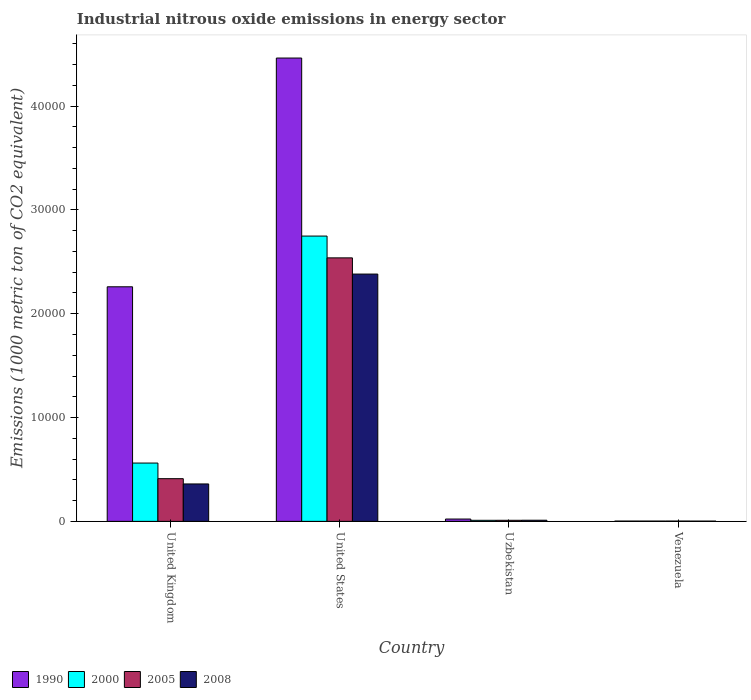How many groups of bars are there?
Make the answer very short. 4. Are the number of bars on each tick of the X-axis equal?
Provide a short and direct response. Yes. How many bars are there on the 1st tick from the right?
Provide a short and direct response. 4. What is the label of the 1st group of bars from the left?
Make the answer very short. United Kingdom. In how many cases, is the number of bars for a given country not equal to the number of legend labels?
Your answer should be compact. 0. What is the amount of industrial nitrous oxide emitted in 2005 in Uzbekistan?
Make the answer very short. 103.2. Across all countries, what is the maximum amount of industrial nitrous oxide emitted in 2000?
Give a very brief answer. 2.75e+04. Across all countries, what is the minimum amount of industrial nitrous oxide emitted in 1990?
Ensure brevity in your answer.  27.9. In which country was the amount of industrial nitrous oxide emitted in 1990 maximum?
Provide a succinct answer. United States. In which country was the amount of industrial nitrous oxide emitted in 2008 minimum?
Offer a terse response. Venezuela. What is the total amount of industrial nitrous oxide emitted in 1990 in the graph?
Ensure brevity in your answer.  6.75e+04. What is the difference between the amount of industrial nitrous oxide emitted in 1990 in United Kingdom and that in United States?
Offer a very short reply. -2.20e+04. What is the difference between the amount of industrial nitrous oxide emitted in 2008 in Venezuela and the amount of industrial nitrous oxide emitted in 2000 in Uzbekistan?
Your response must be concise. -76.2. What is the average amount of industrial nitrous oxide emitted in 1990 per country?
Your answer should be compact. 1.69e+04. What is the difference between the amount of industrial nitrous oxide emitted of/in 2005 and amount of industrial nitrous oxide emitted of/in 2008 in United Kingdom?
Keep it short and to the point. 506.6. What is the ratio of the amount of industrial nitrous oxide emitted in 2005 in United Kingdom to that in Uzbekistan?
Your answer should be very brief. 39.84. Is the amount of industrial nitrous oxide emitted in 1990 in United States less than that in Venezuela?
Your answer should be compact. No. What is the difference between the highest and the second highest amount of industrial nitrous oxide emitted in 2005?
Ensure brevity in your answer.  2.53e+04. What is the difference between the highest and the lowest amount of industrial nitrous oxide emitted in 2008?
Offer a terse response. 2.38e+04. Is the sum of the amount of industrial nitrous oxide emitted in 2008 in United Kingdom and United States greater than the maximum amount of industrial nitrous oxide emitted in 2005 across all countries?
Ensure brevity in your answer.  Yes. What does the 1st bar from the left in United Kingdom represents?
Provide a short and direct response. 1990. Is it the case that in every country, the sum of the amount of industrial nitrous oxide emitted in 2000 and amount of industrial nitrous oxide emitted in 1990 is greater than the amount of industrial nitrous oxide emitted in 2008?
Provide a short and direct response. Yes. What is the difference between two consecutive major ticks on the Y-axis?
Offer a very short reply. 10000. Are the values on the major ticks of Y-axis written in scientific E-notation?
Make the answer very short. No. Does the graph contain grids?
Ensure brevity in your answer.  No. How are the legend labels stacked?
Offer a terse response. Horizontal. What is the title of the graph?
Your answer should be compact. Industrial nitrous oxide emissions in energy sector. What is the label or title of the Y-axis?
Ensure brevity in your answer.  Emissions (1000 metric ton of CO2 equivalent). What is the Emissions (1000 metric ton of CO2 equivalent) of 1990 in United Kingdom?
Keep it short and to the point. 2.26e+04. What is the Emissions (1000 metric ton of CO2 equivalent) in 2000 in United Kingdom?
Offer a very short reply. 5616. What is the Emissions (1000 metric ton of CO2 equivalent) of 2005 in United Kingdom?
Keep it short and to the point. 4111.2. What is the Emissions (1000 metric ton of CO2 equivalent) in 2008 in United Kingdom?
Keep it short and to the point. 3604.6. What is the Emissions (1000 metric ton of CO2 equivalent) of 1990 in United States?
Offer a very short reply. 4.46e+04. What is the Emissions (1000 metric ton of CO2 equivalent) in 2000 in United States?
Offer a very short reply. 2.75e+04. What is the Emissions (1000 metric ton of CO2 equivalent) in 2005 in United States?
Your answer should be very brief. 2.54e+04. What is the Emissions (1000 metric ton of CO2 equivalent) of 2008 in United States?
Your answer should be very brief. 2.38e+04. What is the Emissions (1000 metric ton of CO2 equivalent) of 1990 in Uzbekistan?
Offer a very short reply. 223.2. What is the Emissions (1000 metric ton of CO2 equivalent) of 2000 in Uzbekistan?
Offer a very short reply. 101.6. What is the Emissions (1000 metric ton of CO2 equivalent) in 2005 in Uzbekistan?
Keep it short and to the point. 103.2. What is the Emissions (1000 metric ton of CO2 equivalent) in 2008 in Uzbekistan?
Provide a succinct answer. 109.4. What is the Emissions (1000 metric ton of CO2 equivalent) in 1990 in Venezuela?
Offer a terse response. 27.9. What is the Emissions (1000 metric ton of CO2 equivalent) of 2000 in Venezuela?
Keep it short and to the point. 27.9. What is the Emissions (1000 metric ton of CO2 equivalent) of 2005 in Venezuela?
Your answer should be compact. 30.1. What is the Emissions (1000 metric ton of CO2 equivalent) of 2008 in Venezuela?
Offer a very short reply. 25.4. Across all countries, what is the maximum Emissions (1000 metric ton of CO2 equivalent) of 1990?
Give a very brief answer. 4.46e+04. Across all countries, what is the maximum Emissions (1000 metric ton of CO2 equivalent) in 2000?
Ensure brevity in your answer.  2.75e+04. Across all countries, what is the maximum Emissions (1000 metric ton of CO2 equivalent) of 2005?
Offer a very short reply. 2.54e+04. Across all countries, what is the maximum Emissions (1000 metric ton of CO2 equivalent) of 2008?
Make the answer very short. 2.38e+04. Across all countries, what is the minimum Emissions (1000 metric ton of CO2 equivalent) in 1990?
Give a very brief answer. 27.9. Across all countries, what is the minimum Emissions (1000 metric ton of CO2 equivalent) in 2000?
Provide a succinct answer. 27.9. Across all countries, what is the minimum Emissions (1000 metric ton of CO2 equivalent) in 2005?
Keep it short and to the point. 30.1. Across all countries, what is the minimum Emissions (1000 metric ton of CO2 equivalent) in 2008?
Keep it short and to the point. 25.4. What is the total Emissions (1000 metric ton of CO2 equivalent) in 1990 in the graph?
Your answer should be compact. 6.75e+04. What is the total Emissions (1000 metric ton of CO2 equivalent) of 2000 in the graph?
Keep it short and to the point. 3.32e+04. What is the total Emissions (1000 metric ton of CO2 equivalent) of 2005 in the graph?
Provide a short and direct response. 2.96e+04. What is the total Emissions (1000 metric ton of CO2 equivalent) of 2008 in the graph?
Your answer should be very brief. 2.76e+04. What is the difference between the Emissions (1000 metric ton of CO2 equivalent) of 1990 in United Kingdom and that in United States?
Your answer should be very brief. -2.20e+04. What is the difference between the Emissions (1000 metric ton of CO2 equivalent) of 2000 in United Kingdom and that in United States?
Give a very brief answer. -2.19e+04. What is the difference between the Emissions (1000 metric ton of CO2 equivalent) of 2005 in United Kingdom and that in United States?
Your answer should be very brief. -2.13e+04. What is the difference between the Emissions (1000 metric ton of CO2 equivalent) in 2008 in United Kingdom and that in United States?
Your answer should be compact. -2.02e+04. What is the difference between the Emissions (1000 metric ton of CO2 equivalent) of 1990 in United Kingdom and that in Uzbekistan?
Offer a terse response. 2.24e+04. What is the difference between the Emissions (1000 metric ton of CO2 equivalent) in 2000 in United Kingdom and that in Uzbekistan?
Offer a very short reply. 5514.4. What is the difference between the Emissions (1000 metric ton of CO2 equivalent) of 2005 in United Kingdom and that in Uzbekistan?
Give a very brief answer. 4008. What is the difference between the Emissions (1000 metric ton of CO2 equivalent) in 2008 in United Kingdom and that in Uzbekistan?
Offer a very short reply. 3495.2. What is the difference between the Emissions (1000 metric ton of CO2 equivalent) of 1990 in United Kingdom and that in Venezuela?
Make the answer very short. 2.26e+04. What is the difference between the Emissions (1000 metric ton of CO2 equivalent) of 2000 in United Kingdom and that in Venezuela?
Offer a terse response. 5588.1. What is the difference between the Emissions (1000 metric ton of CO2 equivalent) of 2005 in United Kingdom and that in Venezuela?
Provide a short and direct response. 4081.1. What is the difference between the Emissions (1000 metric ton of CO2 equivalent) in 2008 in United Kingdom and that in Venezuela?
Your response must be concise. 3579.2. What is the difference between the Emissions (1000 metric ton of CO2 equivalent) of 1990 in United States and that in Uzbekistan?
Your response must be concise. 4.44e+04. What is the difference between the Emissions (1000 metric ton of CO2 equivalent) in 2000 in United States and that in Uzbekistan?
Make the answer very short. 2.74e+04. What is the difference between the Emissions (1000 metric ton of CO2 equivalent) of 2005 in United States and that in Uzbekistan?
Give a very brief answer. 2.53e+04. What is the difference between the Emissions (1000 metric ton of CO2 equivalent) in 2008 in United States and that in Uzbekistan?
Provide a short and direct response. 2.37e+04. What is the difference between the Emissions (1000 metric ton of CO2 equivalent) in 1990 in United States and that in Venezuela?
Your answer should be very brief. 4.46e+04. What is the difference between the Emissions (1000 metric ton of CO2 equivalent) in 2000 in United States and that in Venezuela?
Provide a succinct answer. 2.74e+04. What is the difference between the Emissions (1000 metric ton of CO2 equivalent) in 2005 in United States and that in Venezuela?
Offer a terse response. 2.53e+04. What is the difference between the Emissions (1000 metric ton of CO2 equivalent) of 2008 in United States and that in Venezuela?
Provide a short and direct response. 2.38e+04. What is the difference between the Emissions (1000 metric ton of CO2 equivalent) in 1990 in Uzbekistan and that in Venezuela?
Give a very brief answer. 195.3. What is the difference between the Emissions (1000 metric ton of CO2 equivalent) in 2000 in Uzbekistan and that in Venezuela?
Your answer should be very brief. 73.7. What is the difference between the Emissions (1000 metric ton of CO2 equivalent) in 2005 in Uzbekistan and that in Venezuela?
Your answer should be compact. 73.1. What is the difference between the Emissions (1000 metric ton of CO2 equivalent) in 1990 in United Kingdom and the Emissions (1000 metric ton of CO2 equivalent) in 2000 in United States?
Offer a very short reply. -4884.9. What is the difference between the Emissions (1000 metric ton of CO2 equivalent) of 1990 in United Kingdom and the Emissions (1000 metric ton of CO2 equivalent) of 2005 in United States?
Keep it short and to the point. -2785.7. What is the difference between the Emissions (1000 metric ton of CO2 equivalent) of 1990 in United Kingdom and the Emissions (1000 metric ton of CO2 equivalent) of 2008 in United States?
Make the answer very short. -1224.8. What is the difference between the Emissions (1000 metric ton of CO2 equivalent) in 2000 in United Kingdom and the Emissions (1000 metric ton of CO2 equivalent) in 2005 in United States?
Your answer should be very brief. -1.98e+04. What is the difference between the Emissions (1000 metric ton of CO2 equivalent) of 2000 in United Kingdom and the Emissions (1000 metric ton of CO2 equivalent) of 2008 in United States?
Keep it short and to the point. -1.82e+04. What is the difference between the Emissions (1000 metric ton of CO2 equivalent) of 2005 in United Kingdom and the Emissions (1000 metric ton of CO2 equivalent) of 2008 in United States?
Your answer should be compact. -1.97e+04. What is the difference between the Emissions (1000 metric ton of CO2 equivalent) in 1990 in United Kingdom and the Emissions (1000 metric ton of CO2 equivalent) in 2000 in Uzbekistan?
Make the answer very short. 2.25e+04. What is the difference between the Emissions (1000 metric ton of CO2 equivalent) in 1990 in United Kingdom and the Emissions (1000 metric ton of CO2 equivalent) in 2005 in Uzbekistan?
Keep it short and to the point. 2.25e+04. What is the difference between the Emissions (1000 metric ton of CO2 equivalent) in 1990 in United Kingdom and the Emissions (1000 metric ton of CO2 equivalent) in 2008 in Uzbekistan?
Provide a short and direct response. 2.25e+04. What is the difference between the Emissions (1000 metric ton of CO2 equivalent) of 2000 in United Kingdom and the Emissions (1000 metric ton of CO2 equivalent) of 2005 in Uzbekistan?
Give a very brief answer. 5512.8. What is the difference between the Emissions (1000 metric ton of CO2 equivalent) in 2000 in United Kingdom and the Emissions (1000 metric ton of CO2 equivalent) in 2008 in Uzbekistan?
Ensure brevity in your answer.  5506.6. What is the difference between the Emissions (1000 metric ton of CO2 equivalent) in 2005 in United Kingdom and the Emissions (1000 metric ton of CO2 equivalent) in 2008 in Uzbekistan?
Offer a very short reply. 4001.8. What is the difference between the Emissions (1000 metric ton of CO2 equivalent) in 1990 in United Kingdom and the Emissions (1000 metric ton of CO2 equivalent) in 2000 in Venezuela?
Your answer should be very brief. 2.26e+04. What is the difference between the Emissions (1000 metric ton of CO2 equivalent) in 1990 in United Kingdom and the Emissions (1000 metric ton of CO2 equivalent) in 2005 in Venezuela?
Offer a terse response. 2.26e+04. What is the difference between the Emissions (1000 metric ton of CO2 equivalent) in 1990 in United Kingdom and the Emissions (1000 metric ton of CO2 equivalent) in 2008 in Venezuela?
Offer a very short reply. 2.26e+04. What is the difference between the Emissions (1000 metric ton of CO2 equivalent) in 2000 in United Kingdom and the Emissions (1000 metric ton of CO2 equivalent) in 2005 in Venezuela?
Offer a very short reply. 5585.9. What is the difference between the Emissions (1000 metric ton of CO2 equivalent) of 2000 in United Kingdom and the Emissions (1000 metric ton of CO2 equivalent) of 2008 in Venezuela?
Your response must be concise. 5590.6. What is the difference between the Emissions (1000 metric ton of CO2 equivalent) of 2005 in United Kingdom and the Emissions (1000 metric ton of CO2 equivalent) of 2008 in Venezuela?
Give a very brief answer. 4085.8. What is the difference between the Emissions (1000 metric ton of CO2 equivalent) in 1990 in United States and the Emissions (1000 metric ton of CO2 equivalent) in 2000 in Uzbekistan?
Give a very brief answer. 4.45e+04. What is the difference between the Emissions (1000 metric ton of CO2 equivalent) in 1990 in United States and the Emissions (1000 metric ton of CO2 equivalent) in 2005 in Uzbekistan?
Ensure brevity in your answer.  4.45e+04. What is the difference between the Emissions (1000 metric ton of CO2 equivalent) of 1990 in United States and the Emissions (1000 metric ton of CO2 equivalent) of 2008 in Uzbekistan?
Provide a short and direct response. 4.45e+04. What is the difference between the Emissions (1000 metric ton of CO2 equivalent) of 2000 in United States and the Emissions (1000 metric ton of CO2 equivalent) of 2005 in Uzbekistan?
Provide a succinct answer. 2.74e+04. What is the difference between the Emissions (1000 metric ton of CO2 equivalent) in 2000 in United States and the Emissions (1000 metric ton of CO2 equivalent) in 2008 in Uzbekistan?
Offer a very short reply. 2.74e+04. What is the difference between the Emissions (1000 metric ton of CO2 equivalent) in 2005 in United States and the Emissions (1000 metric ton of CO2 equivalent) in 2008 in Uzbekistan?
Your answer should be very brief. 2.53e+04. What is the difference between the Emissions (1000 metric ton of CO2 equivalent) in 1990 in United States and the Emissions (1000 metric ton of CO2 equivalent) in 2000 in Venezuela?
Keep it short and to the point. 4.46e+04. What is the difference between the Emissions (1000 metric ton of CO2 equivalent) of 1990 in United States and the Emissions (1000 metric ton of CO2 equivalent) of 2005 in Venezuela?
Offer a very short reply. 4.46e+04. What is the difference between the Emissions (1000 metric ton of CO2 equivalent) in 1990 in United States and the Emissions (1000 metric ton of CO2 equivalent) in 2008 in Venezuela?
Provide a short and direct response. 4.46e+04. What is the difference between the Emissions (1000 metric ton of CO2 equivalent) in 2000 in United States and the Emissions (1000 metric ton of CO2 equivalent) in 2005 in Venezuela?
Offer a very short reply. 2.74e+04. What is the difference between the Emissions (1000 metric ton of CO2 equivalent) in 2000 in United States and the Emissions (1000 metric ton of CO2 equivalent) in 2008 in Venezuela?
Your answer should be compact. 2.75e+04. What is the difference between the Emissions (1000 metric ton of CO2 equivalent) in 2005 in United States and the Emissions (1000 metric ton of CO2 equivalent) in 2008 in Venezuela?
Offer a terse response. 2.54e+04. What is the difference between the Emissions (1000 metric ton of CO2 equivalent) in 1990 in Uzbekistan and the Emissions (1000 metric ton of CO2 equivalent) in 2000 in Venezuela?
Offer a terse response. 195.3. What is the difference between the Emissions (1000 metric ton of CO2 equivalent) in 1990 in Uzbekistan and the Emissions (1000 metric ton of CO2 equivalent) in 2005 in Venezuela?
Ensure brevity in your answer.  193.1. What is the difference between the Emissions (1000 metric ton of CO2 equivalent) of 1990 in Uzbekistan and the Emissions (1000 metric ton of CO2 equivalent) of 2008 in Venezuela?
Your response must be concise. 197.8. What is the difference between the Emissions (1000 metric ton of CO2 equivalent) of 2000 in Uzbekistan and the Emissions (1000 metric ton of CO2 equivalent) of 2005 in Venezuela?
Offer a terse response. 71.5. What is the difference between the Emissions (1000 metric ton of CO2 equivalent) of 2000 in Uzbekistan and the Emissions (1000 metric ton of CO2 equivalent) of 2008 in Venezuela?
Offer a terse response. 76.2. What is the difference between the Emissions (1000 metric ton of CO2 equivalent) of 2005 in Uzbekistan and the Emissions (1000 metric ton of CO2 equivalent) of 2008 in Venezuela?
Provide a succinct answer. 77.8. What is the average Emissions (1000 metric ton of CO2 equivalent) of 1990 per country?
Your response must be concise. 1.69e+04. What is the average Emissions (1000 metric ton of CO2 equivalent) in 2000 per country?
Provide a short and direct response. 8305.85. What is the average Emissions (1000 metric ton of CO2 equivalent) in 2005 per country?
Keep it short and to the point. 7405.8. What is the average Emissions (1000 metric ton of CO2 equivalent) of 2008 per country?
Offer a very short reply. 6889.3. What is the difference between the Emissions (1000 metric ton of CO2 equivalent) in 1990 and Emissions (1000 metric ton of CO2 equivalent) in 2000 in United Kingdom?
Make the answer very short. 1.70e+04. What is the difference between the Emissions (1000 metric ton of CO2 equivalent) of 1990 and Emissions (1000 metric ton of CO2 equivalent) of 2005 in United Kingdom?
Provide a succinct answer. 1.85e+04. What is the difference between the Emissions (1000 metric ton of CO2 equivalent) of 1990 and Emissions (1000 metric ton of CO2 equivalent) of 2008 in United Kingdom?
Offer a terse response. 1.90e+04. What is the difference between the Emissions (1000 metric ton of CO2 equivalent) in 2000 and Emissions (1000 metric ton of CO2 equivalent) in 2005 in United Kingdom?
Provide a succinct answer. 1504.8. What is the difference between the Emissions (1000 metric ton of CO2 equivalent) of 2000 and Emissions (1000 metric ton of CO2 equivalent) of 2008 in United Kingdom?
Your response must be concise. 2011.4. What is the difference between the Emissions (1000 metric ton of CO2 equivalent) in 2005 and Emissions (1000 metric ton of CO2 equivalent) in 2008 in United Kingdom?
Offer a terse response. 506.6. What is the difference between the Emissions (1000 metric ton of CO2 equivalent) in 1990 and Emissions (1000 metric ton of CO2 equivalent) in 2000 in United States?
Provide a succinct answer. 1.71e+04. What is the difference between the Emissions (1000 metric ton of CO2 equivalent) of 1990 and Emissions (1000 metric ton of CO2 equivalent) of 2005 in United States?
Provide a short and direct response. 1.92e+04. What is the difference between the Emissions (1000 metric ton of CO2 equivalent) in 1990 and Emissions (1000 metric ton of CO2 equivalent) in 2008 in United States?
Your answer should be very brief. 2.08e+04. What is the difference between the Emissions (1000 metric ton of CO2 equivalent) of 2000 and Emissions (1000 metric ton of CO2 equivalent) of 2005 in United States?
Make the answer very short. 2099.2. What is the difference between the Emissions (1000 metric ton of CO2 equivalent) of 2000 and Emissions (1000 metric ton of CO2 equivalent) of 2008 in United States?
Make the answer very short. 3660.1. What is the difference between the Emissions (1000 metric ton of CO2 equivalent) in 2005 and Emissions (1000 metric ton of CO2 equivalent) in 2008 in United States?
Your answer should be compact. 1560.9. What is the difference between the Emissions (1000 metric ton of CO2 equivalent) in 1990 and Emissions (1000 metric ton of CO2 equivalent) in 2000 in Uzbekistan?
Give a very brief answer. 121.6. What is the difference between the Emissions (1000 metric ton of CO2 equivalent) of 1990 and Emissions (1000 metric ton of CO2 equivalent) of 2005 in Uzbekistan?
Your response must be concise. 120. What is the difference between the Emissions (1000 metric ton of CO2 equivalent) in 1990 and Emissions (1000 metric ton of CO2 equivalent) in 2008 in Uzbekistan?
Your answer should be very brief. 113.8. What is the difference between the Emissions (1000 metric ton of CO2 equivalent) of 2000 and Emissions (1000 metric ton of CO2 equivalent) of 2005 in Uzbekistan?
Offer a terse response. -1.6. What is the difference between the Emissions (1000 metric ton of CO2 equivalent) of 2000 and Emissions (1000 metric ton of CO2 equivalent) of 2008 in Uzbekistan?
Keep it short and to the point. -7.8. What is the difference between the Emissions (1000 metric ton of CO2 equivalent) in 2005 and Emissions (1000 metric ton of CO2 equivalent) in 2008 in Uzbekistan?
Your answer should be very brief. -6.2. What is the difference between the Emissions (1000 metric ton of CO2 equivalent) in 2000 and Emissions (1000 metric ton of CO2 equivalent) in 2008 in Venezuela?
Offer a very short reply. 2.5. What is the difference between the Emissions (1000 metric ton of CO2 equivalent) in 2005 and Emissions (1000 metric ton of CO2 equivalent) in 2008 in Venezuela?
Provide a succinct answer. 4.7. What is the ratio of the Emissions (1000 metric ton of CO2 equivalent) of 1990 in United Kingdom to that in United States?
Give a very brief answer. 0.51. What is the ratio of the Emissions (1000 metric ton of CO2 equivalent) of 2000 in United Kingdom to that in United States?
Keep it short and to the point. 0.2. What is the ratio of the Emissions (1000 metric ton of CO2 equivalent) in 2005 in United Kingdom to that in United States?
Your answer should be compact. 0.16. What is the ratio of the Emissions (1000 metric ton of CO2 equivalent) of 2008 in United Kingdom to that in United States?
Offer a terse response. 0.15. What is the ratio of the Emissions (1000 metric ton of CO2 equivalent) of 1990 in United Kingdom to that in Uzbekistan?
Provide a succinct answer. 101.22. What is the ratio of the Emissions (1000 metric ton of CO2 equivalent) in 2000 in United Kingdom to that in Uzbekistan?
Offer a terse response. 55.28. What is the ratio of the Emissions (1000 metric ton of CO2 equivalent) in 2005 in United Kingdom to that in Uzbekistan?
Provide a succinct answer. 39.84. What is the ratio of the Emissions (1000 metric ton of CO2 equivalent) in 2008 in United Kingdom to that in Uzbekistan?
Give a very brief answer. 32.95. What is the ratio of the Emissions (1000 metric ton of CO2 equivalent) in 1990 in United Kingdom to that in Venezuela?
Provide a short and direct response. 809.78. What is the ratio of the Emissions (1000 metric ton of CO2 equivalent) in 2000 in United Kingdom to that in Venezuela?
Your answer should be compact. 201.29. What is the ratio of the Emissions (1000 metric ton of CO2 equivalent) of 2005 in United Kingdom to that in Venezuela?
Keep it short and to the point. 136.58. What is the ratio of the Emissions (1000 metric ton of CO2 equivalent) in 2008 in United Kingdom to that in Venezuela?
Ensure brevity in your answer.  141.91. What is the ratio of the Emissions (1000 metric ton of CO2 equivalent) in 1990 in United States to that in Uzbekistan?
Keep it short and to the point. 199.93. What is the ratio of the Emissions (1000 metric ton of CO2 equivalent) in 2000 in United States to that in Uzbekistan?
Make the answer very short. 270.45. What is the ratio of the Emissions (1000 metric ton of CO2 equivalent) of 2005 in United States to that in Uzbekistan?
Offer a very short reply. 245.92. What is the ratio of the Emissions (1000 metric ton of CO2 equivalent) of 2008 in United States to that in Uzbekistan?
Offer a very short reply. 217.71. What is the ratio of the Emissions (1000 metric ton of CO2 equivalent) of 1990 in United States to that in Venezuela?
Keep it short and to the point. 1599.46. What is the ratio of the Emissions (1000 metric ton of CO2 equivalent) in 2000 in United States to that in Venezuela?
Offer a very short reply. 984.87. What is the ratio of the Emissions (1000 metric ton of CO2 equivalent) of 2005 in United States to that in Venezuela?
Keep it short and to the point. 843.15. What is the ratio of the Emissions (1000 metric ton of CO2 equivalent) in 2008 in United States to that in Venezuela?
Your answer should be very brief. 937.71. What is the ratio of the Emissions (1000 metric ton of CO2 equivalent) of 1990 in Uzbekistan to that in Venezuela?
Offer a terse response. 8. What is the ratio of the Emissions (1000 metric ton of CO2 equivalent) of 2000 in Uzbekistan to that in Venezuela?
Your answer should be compact. 3.64. What is the ratio of the Emissions (1000 metric ton of CO2 equivalent) in 2005 in Uzbekistan to that in Venezuela?
Offer a terse response. 3.43. What is the ratio of the Emissions (1000 metric ton of CO2 equivalent) of 2008 in Uzbekistan to that in Venezuela?
Keep it short and to the point. 4.31. What is the difference between the highest and the second highest Emissions (1000 metric ton of CO2 equivalent) of 1990?
Your response must be concise. 2.20e+04. What is the difference between the highest and the second highest Emissions (1000 metric ton of CO2 equivalent) of 2000?
Provide a short and direct response. 2.19e+04. What is the difference between the highest and the second highest Emissions (1000 metric ton of CO2 equivalent) of 2005?
Keep it short and to the point. 2.13e+04. What is the difference between the highest and the second highest Emissions (1000 metric ton of CO2 equivalent) of 2008?
Offer a terse response. 2.02e+04. What is the difference between the highest and the lowest Emissions (1000 metric ton of CO2 equivalent) in 1990?
Your response must be concise. 4.46e+04. What is the difference between the highest and the lowest Emissions (1000 metric ton of CO2 equivalent) in 2000?
Ensure brevity in your answer.  2.74e+04. What is the difference between the highest and the lowest Emissions (1000 metric ton of CO2 equivalent) in 2005?
Give a very brief answer. 2.53e+04. What is the difference between the highest and the lowest Emissions (1000 metric ton of CO2 equivalent) of 2008?
Your answer should be very brief. 2.38e+04. 